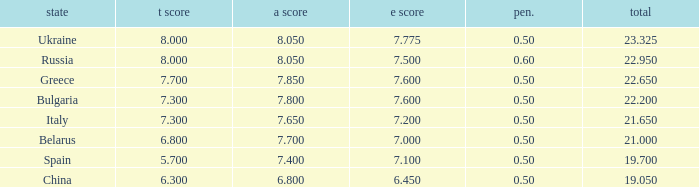What E score has the T score of 8 and a number smaller than 22.95? None. 